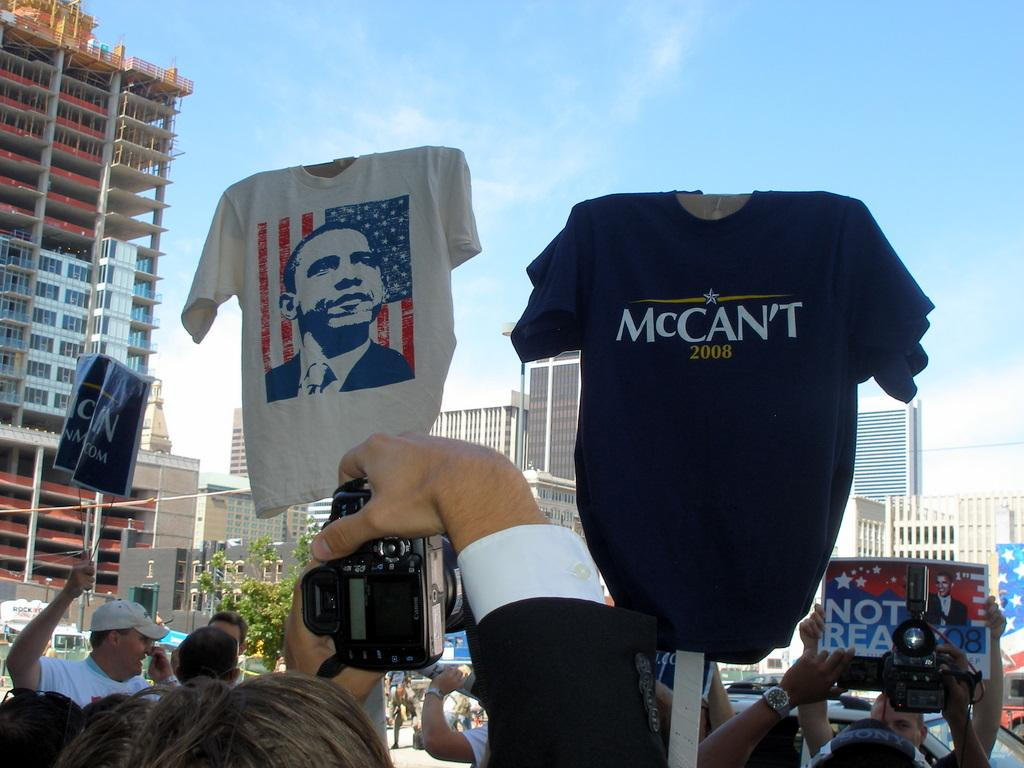<image>
Present a compact description of the photo's key features. At an outdoor demonstration a black t-shit with McCan't 2008 on the front is raised in the air. 